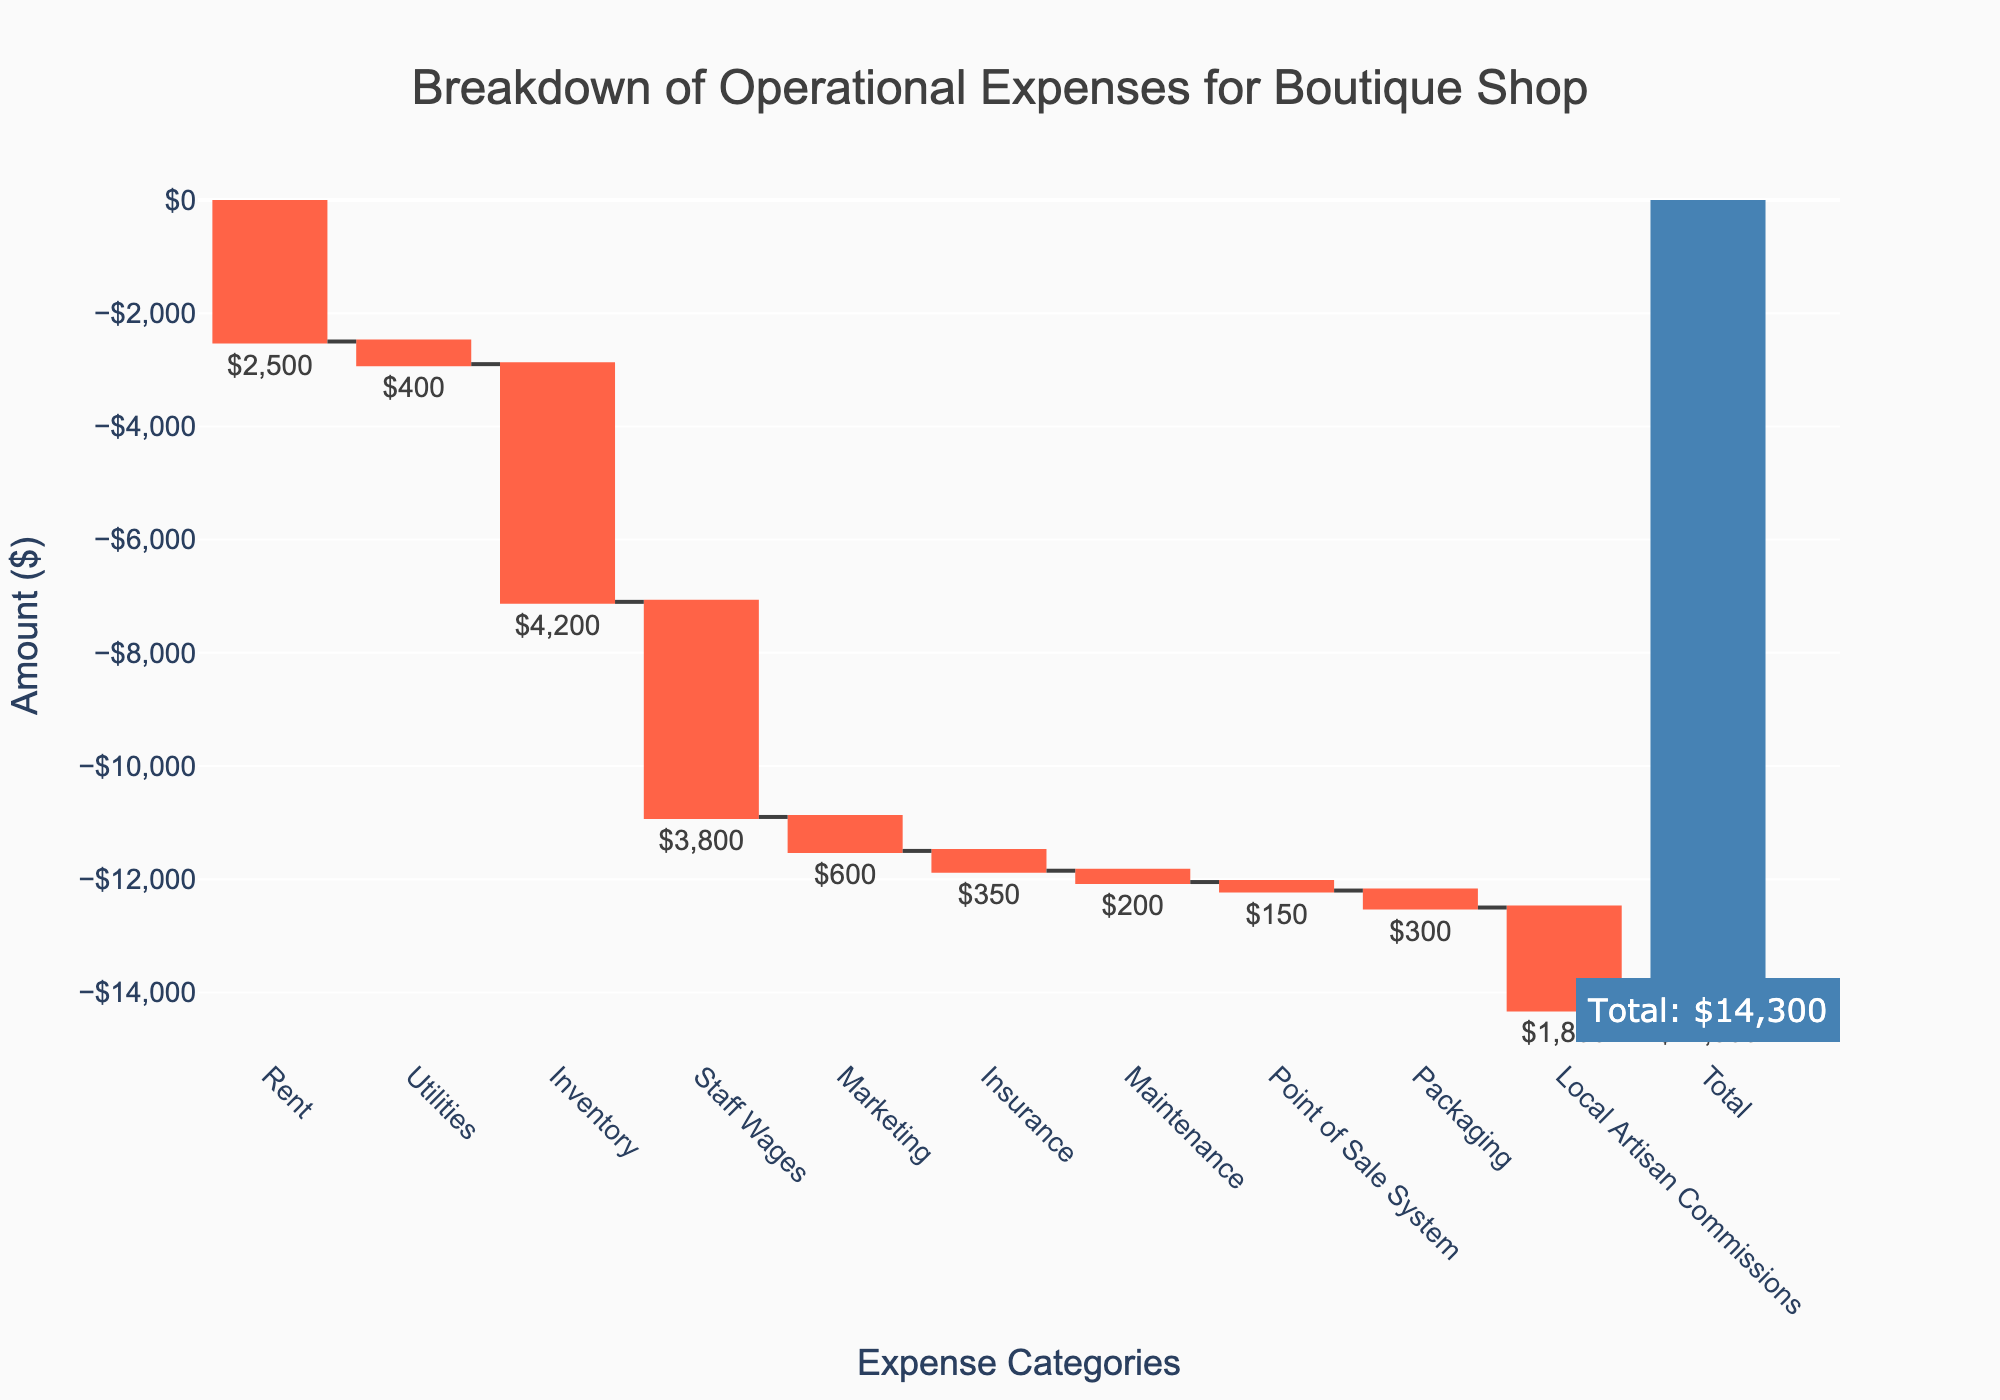What's the title of the figure? The title of the figure is displayed prominently at the top in a large font. It reads "Breakdown of Operational Expenses for Boutique Shop".
Answer: Breakdown of Operational Expenses for Boutique Shop What does the total amount represent in the waterfall chart? The total amount represents the sum of all individual expenses, showing the overall operational expenses for the boutique shop. It's calculated by summing all the negative values in the chart. Visually, it is shown at the end of the x-axis with a specific annotation.
Answer: -$14,300 How much does the shop spend on Rent and Utilities combined? Rent is -$2,500 and Utilities is -$400. Combining these expenses involves summing these two values: -$2,500 + -$400 = -$2,900.
Answer: -$2,900 Which expense category has the highest value? The highest value can be identified by observing the bar that has the longest length in the negative direction. In this chart, "Inventory" has the highest absolute value, indicating it has the highest cost.
Answer: Inventory How does the shop expense on Marketing compare to Packaging? By comparing the lengths of the bars corresponding to Marketing and Packaging, the Marketing expense is -$600, while Packaging expense is -$300.
Answer: Marketing is double Packaging What are the total expenses incurred on Staff Wages, Marketing, Insurance, and Maintenance? To find the total expenses incurred in these categories, sum up the individual expenses: -$3,800 (Staff Wages) + -$600 (Marketing) + -$350 (Insurance) + -$200 (Maintenance) = -$4,950.
Answer: -$4,950 What is the difference between the highest single expense and the lowest single expense? The highest single expense is "Inventory" at -$4,200. The lowest single expense is "Point of Sale System" at -$150. The difference is calculated as -$4,200 - (-$150) = -$4,050.
Answer: -$4,050 How much more does the shop spend on Local Artisan Commissions compared to Rent? Local Artisan Commissions cost -$1,800 and Rent costs -$2,500. The difference between these expenses is -$2,500 - -$1,800 = -$700. The shop spends $700 more on Rent than on Local Artisan Commissions.
Answer: $700 more on Rent 